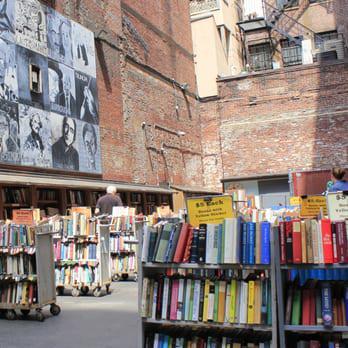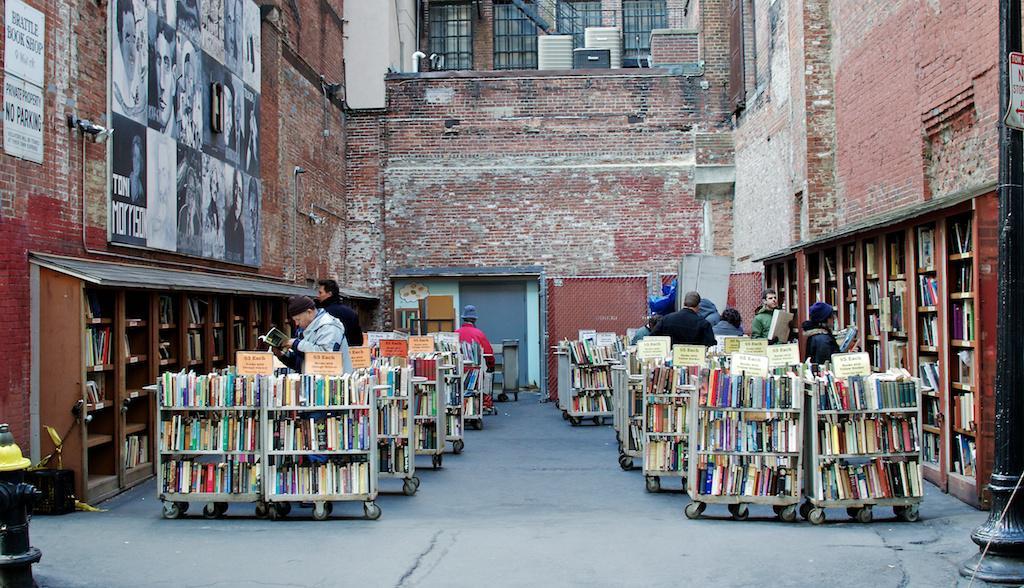The first image is the image on the left, the second image is the image on the right. Evaluate the accuracy of this statement regarding the images: "A red sign is attached and perpendicular next to a window of a dark colored building.". Is it true? Answer yes or no. No. 